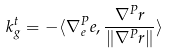<formula> <loc_0><loc_0><loc_500><loc_500>k _ { g } ^ { t } = - \langle \nabla _ { e } ^ { P } e , \frac { \nabla ^ { P } r } { \| \nabla ^ { P } r \| } \rangle</formula> 